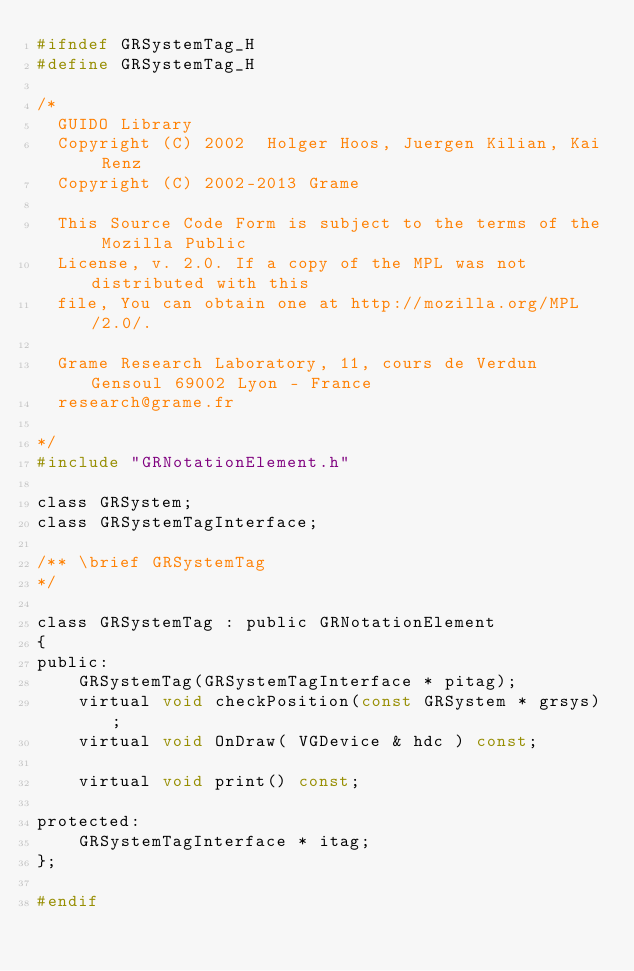<code> <loc_0><loc_0><loc_500><loc_500><_C_>#ifndef GRSystemTag_H
#define GRSystemTag_H

/*
  GUIDO Library
  Copyright (C) 2002  Holger Hoos, Juergen Kilian, Kai Renz
  Copyright (C) 2002-2013 Grame

  This Source Code Form is subject to the terms of the Mozilla Public
  License, v. 2.0. If a copy of the MPL was not distributed with this
  file, You can obtain one at http://mozilla.org/MPL/2.0/.

  Grame Research Laboratory, 11, cours de Verdun Gensoul 69002 Lyon - France
  research@grame.fr

*/
#include "GRNotationElement.h"

class GRSystem;
class GRSystemTagInterface;

/** \brief GRSystemTag
*/

class GRSystemTag : public GRNotationElement
{
public:
	GRSystemTag(GRSystemTagInterface * pitag);
	virtual void checkPosition(const GRSystem * grsys);
	virtual void OnDraw( VGDevice & hdc ) const;

	virtual void print() const;

protected:
	GRSystemTagInterface * itag;
};

#endif
</code> 